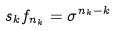Convert formula to latex. <formula><loc_0><loc_0><loc_500><loc_500>s _ { k } f _ { n _ { k } } = \sigma ^ { n _ { k } - k }</formula> 